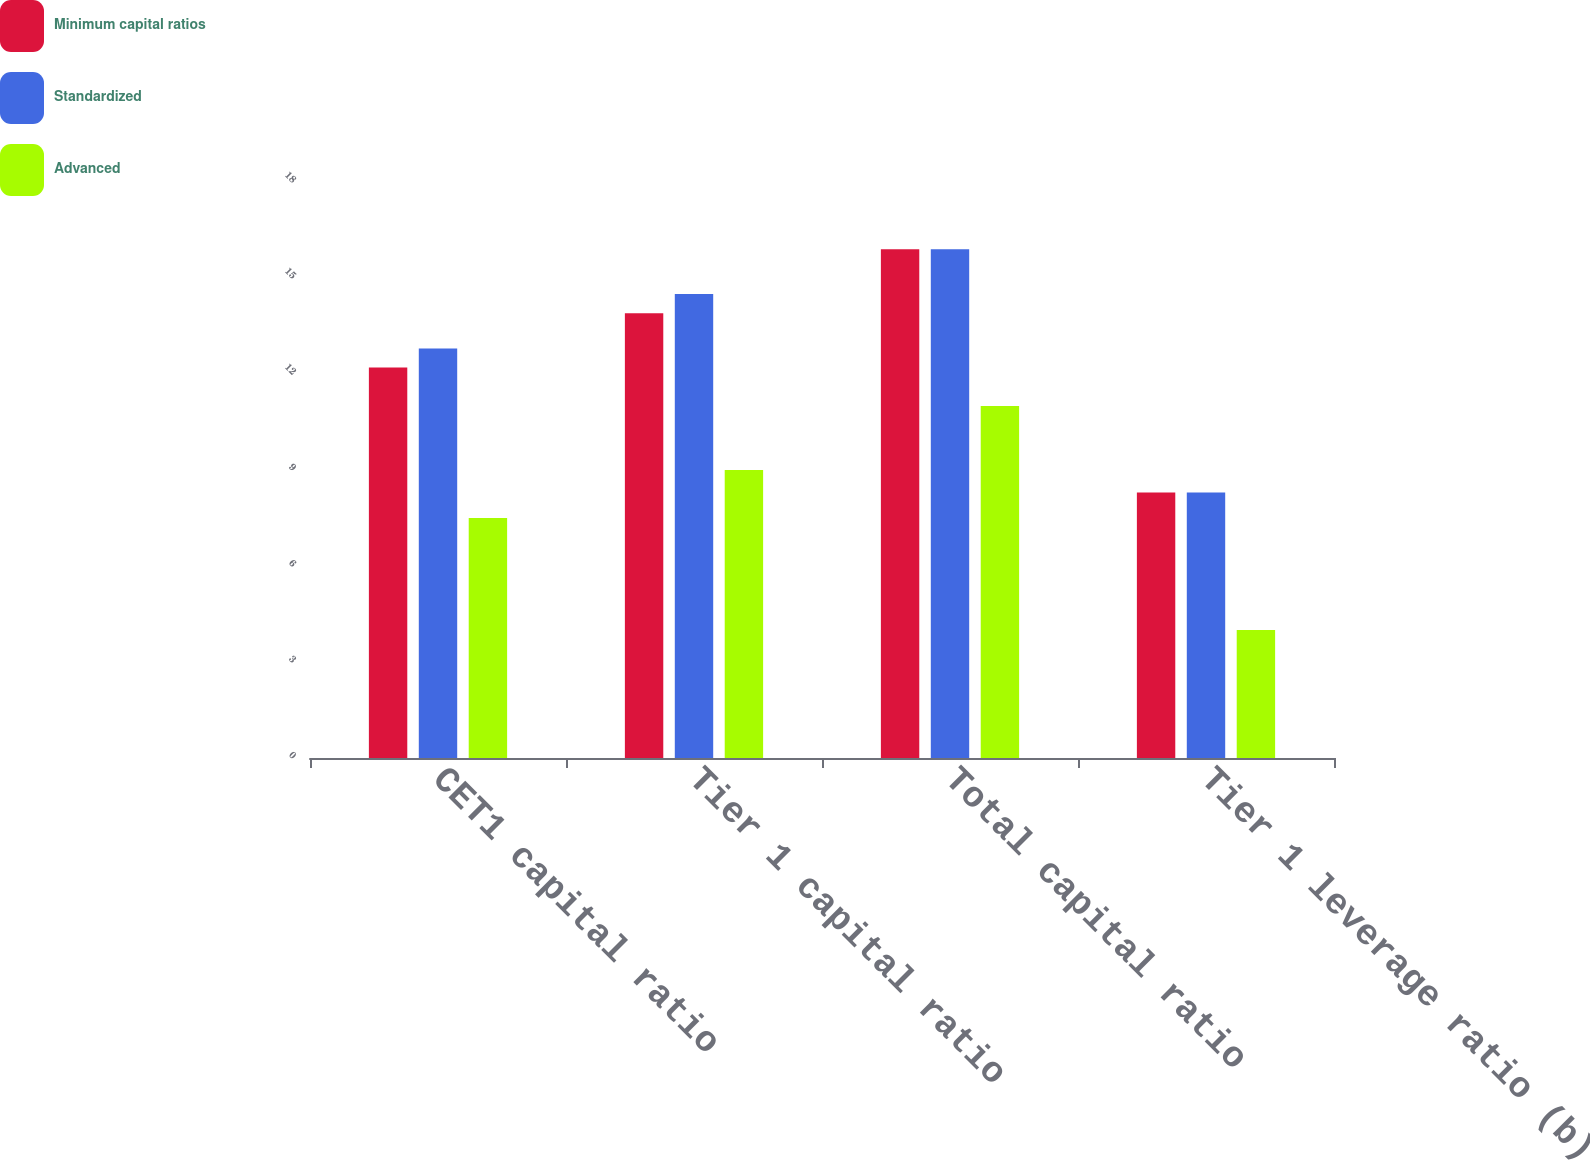Convert chart. <chart><loc_0><loc_0><loc_500><loc_500><stacked_bar_chart><ecel><fcel>CET1 capital ratio<fcel>Tier 1 capital ratio<fcel>Total capital ratio<fcel>Tier 1 leverage ratio (b)<nl><fcel>Minimum capital ratios<fcel>12.2<fcel>13.9<fcel>15.9<fcel>8.3<nl><fcel>Standardized<fcel>12.8<fcel>14.5<fcel>15.9<fcel>8.3<nl><fcel>Advanced<fcel>7.5<fcel>9<fcel>11<fcel>4<nl></chart> 